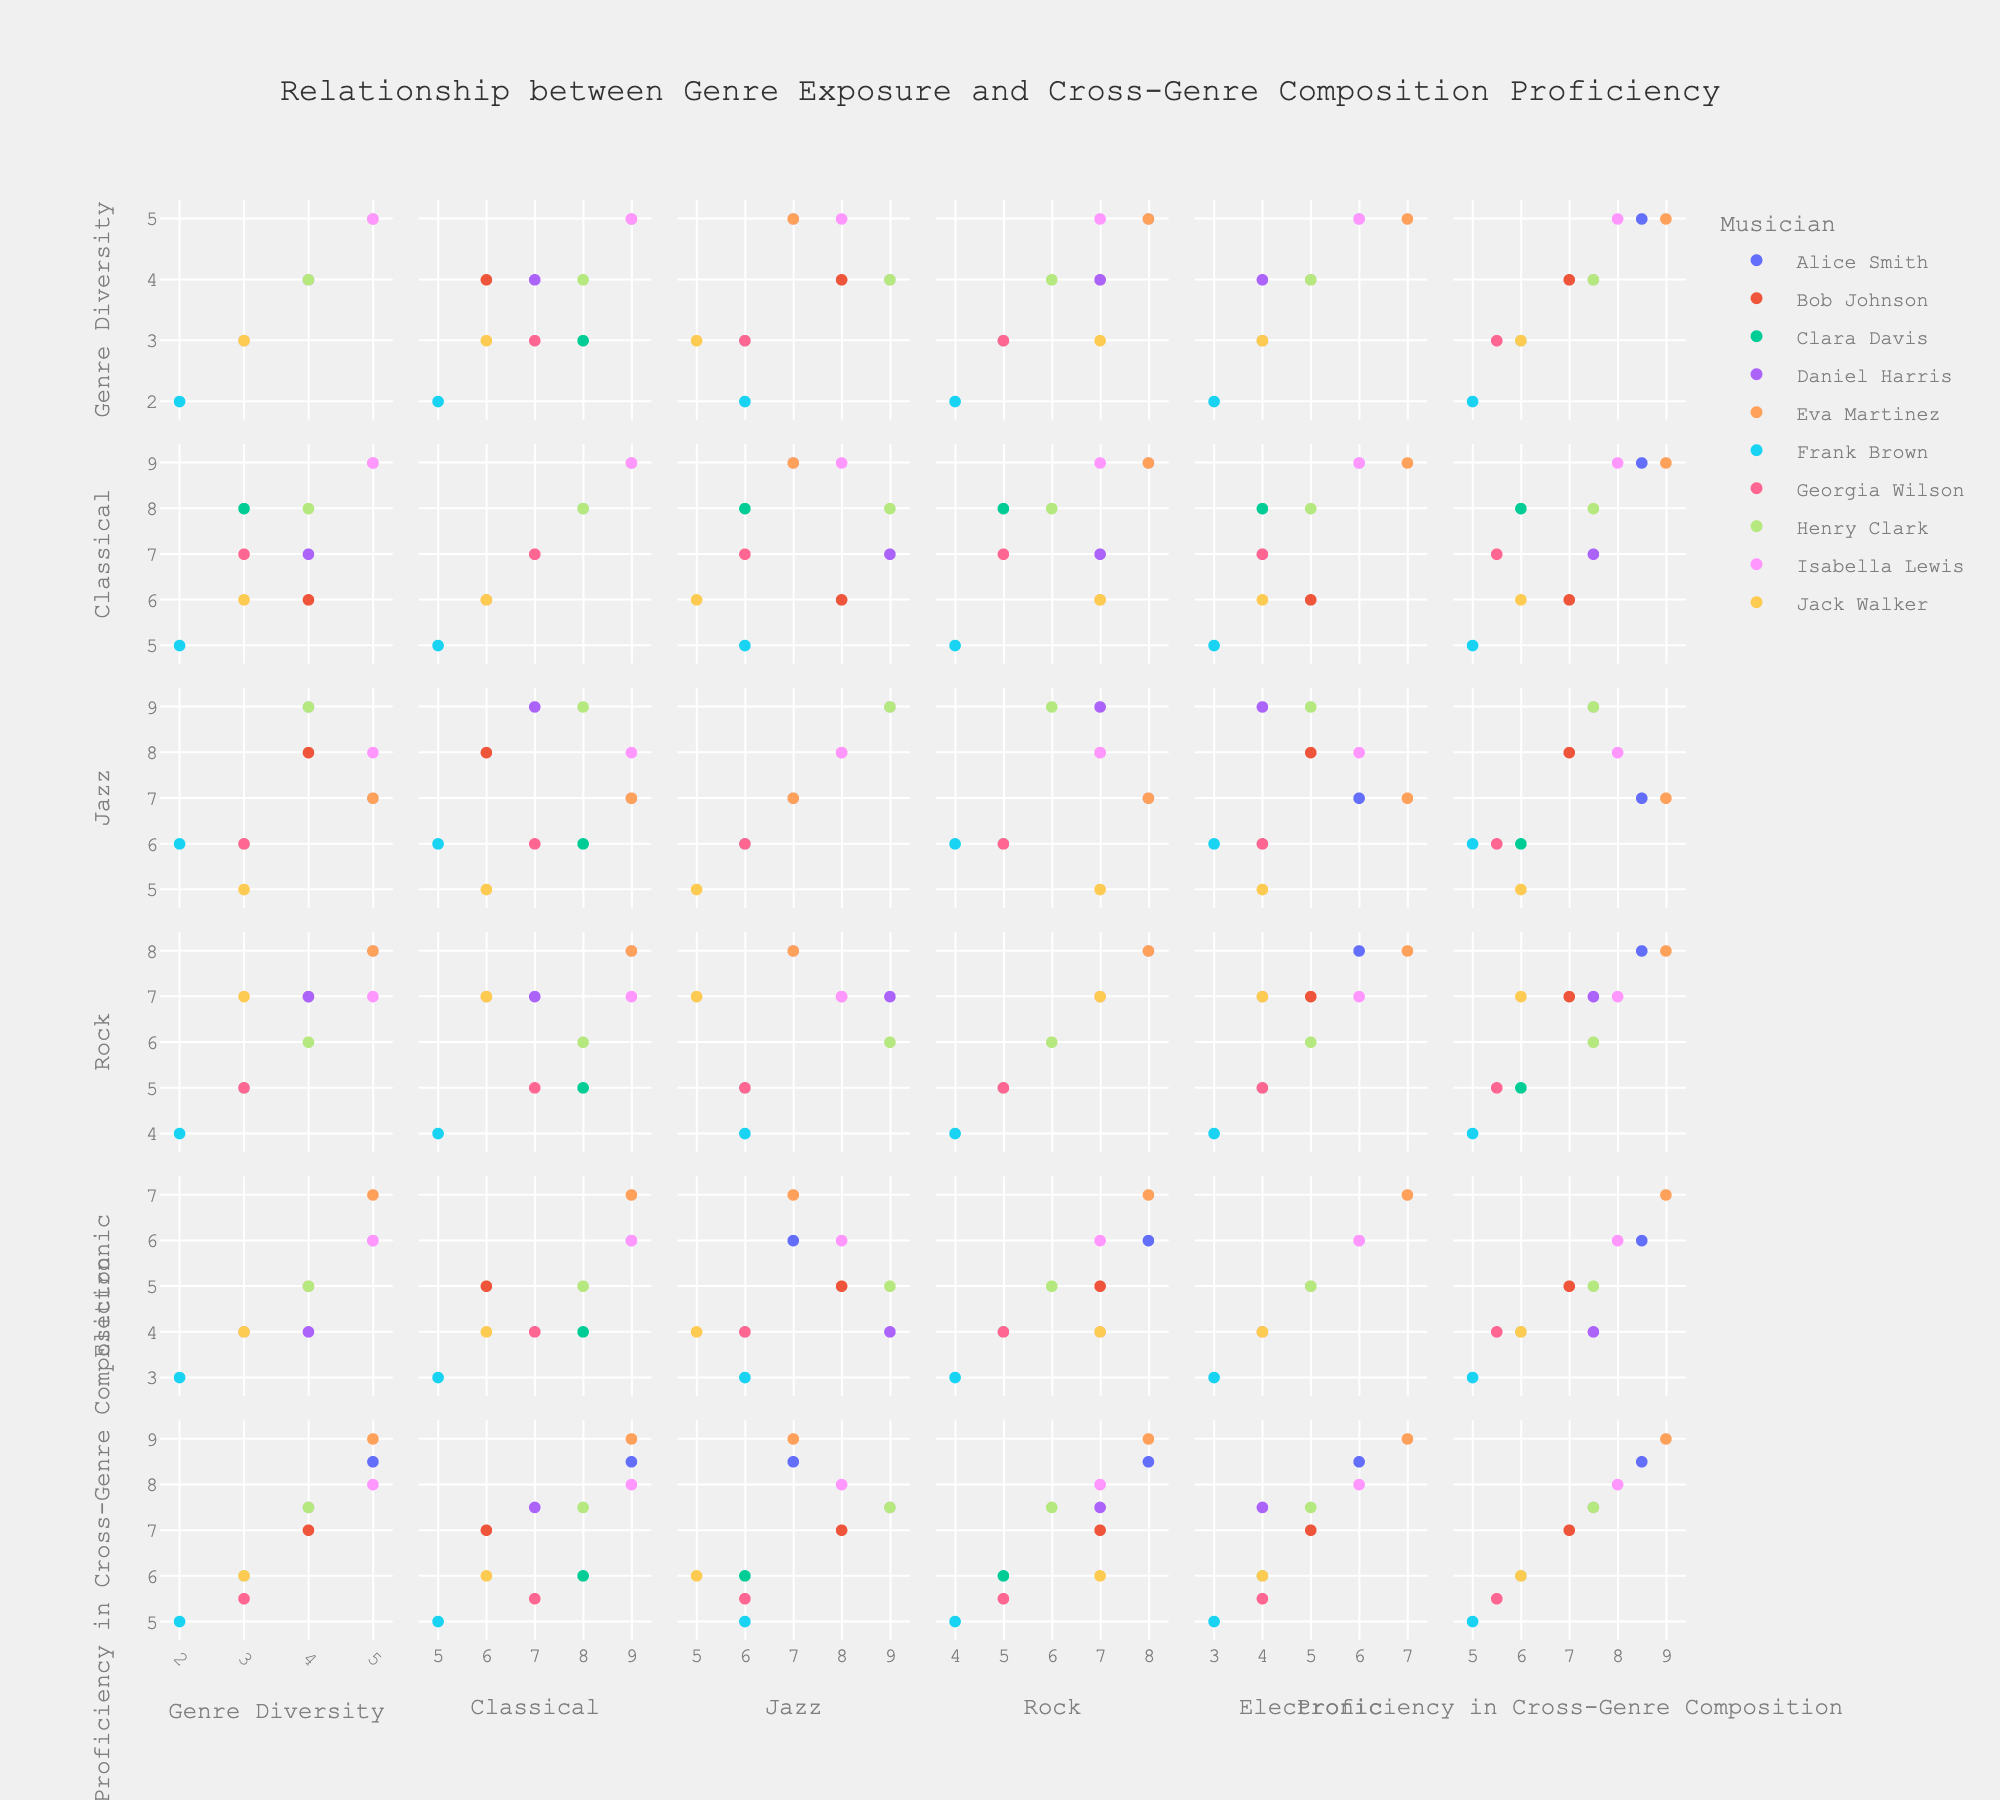Who shows the highest proficiency in cross-genre composition? The SPLOM will show each musician's proficiency in cross-genre composition on the plot. By identifying the maximum value in the respective axis or plot for "Proficiency in Cross-Genre Composition," we can find the musician.
Answer: Eva Martinez Which two musicians have the most similar genre diversity? Look at the "Genre Diversity" dimension and compare the points. The values closest to each other represent musicians with similar genre diversity.
Answer: Alice Smith and Eva Martinez How does exposure to classical music correlate with proficiency in cross-genre composition? Examine the scatter plot matrix cells showing "Exposure to Classical" versus "Proficiency in Cross-Genre Composition." A general trend or lack thereof will be visible.
Answer: Positive correlation Which genre exposure seems to have the least impact on cross-genre composition proficiency? Analyze each scatter plot comparing different genre exposures with "Proficiency in Cross-Genre Composition," and identify which plot shows the least visual correlation, with points scattered without any observable pattern.
Answer: Exposure to Electronic Is there any outlier in the plot comparing genre diversity and proficiency in cross-genre composition? Check the scatter plot matrix cell comparing "Genre Diversity" and "Proficiency in Cross-Genre Composition." An outlier would be a point significantly apart from others.
Answer: No What is the average exposure to Jazz for musicians with a proficiency higher than 7.0? Identify musicians with proficiency > 7.0 from the scatter plots, then calculate the average "Exposure to Jazz" for those selected points.
Answer: 7.33 Among those with highest exposure to Rock, who has the lowest proficiency in cross-genre composition? Identify the points with the highest "Exposure to Rock," then compare their "Proficiency in Cross-Genre Composition" to find the lowest.
Answer: Bob Johnson Which musician has the highest exposure to Classical and how does their cross-genre proficiency compare to others? Find the musician whose data point shows the highest value in "Exposure to Classical" and compare the associated "Proficiency in Cross-Genre Composition" value with other points in that dimension.
Answer: Eva Martinez, high proficiency How many musicians show a genre diversity of exactly 4? Count the data points in the "Genre Diversity" dimension at the value of 4.
Answer: 3 Do musicians with a higher genre diversity tend to have a higher proficiency in cross-genre composition? Look for a trend line or general pattern in the scatter plot cell comparing "Genre Diversity" and "Proficiency in Cross-Genre Composition." This can indicate whether higher diversity often correlates with higher proficiency.
Answer: Yes 